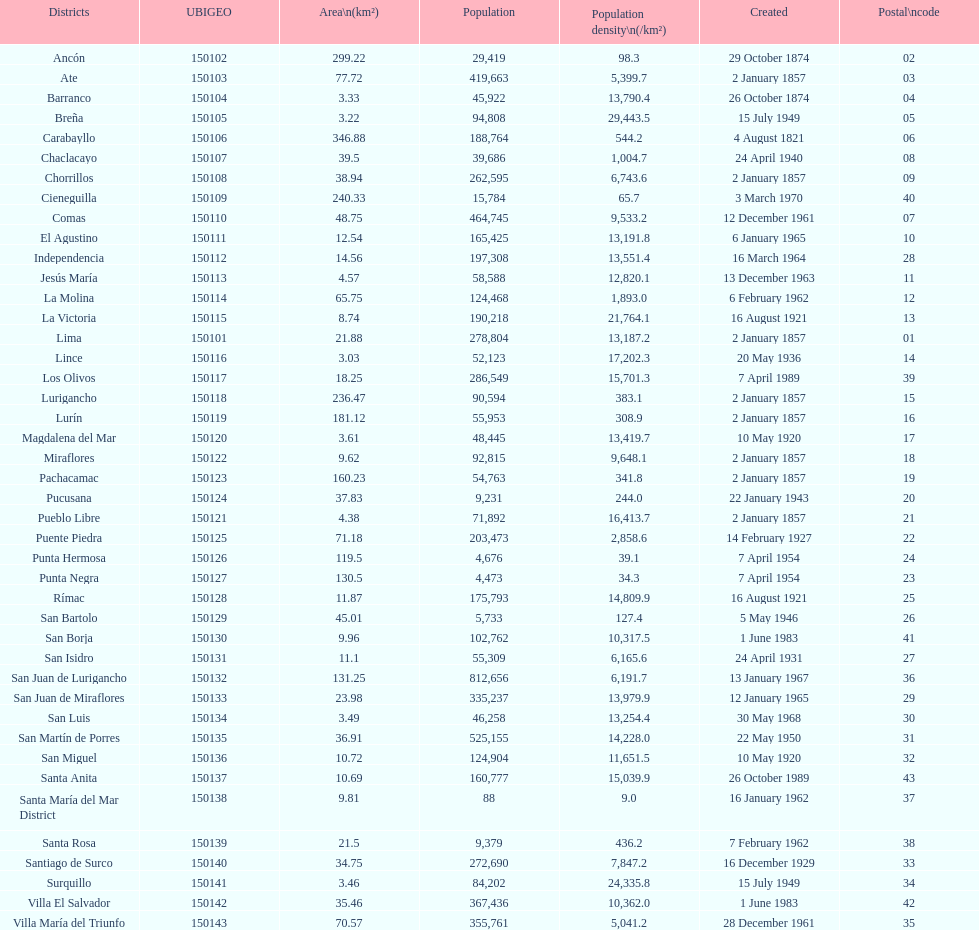Give me the full table as a dictionary. {'header': ['Districts', 'UBIGEO', 'Area\\n(km²)', 'Population', 'Population density\\n(/km²)', 'Created', 'Postal\\ncode'], 'rows': [['Ancón', '150102', '299.22', '29,419', '98.3', '29 October 1874', '02'], ['Ate', '150103', '77.72', '419,663', '5,399.7', '2 January 1857', '03'], ['Barranco', '150104', '3.33', '45,922', '13,790.4', '26 October 1874', '04'], ['Breña', '150105', '3.22', '94,808', '29,443.5', '15 July 1949', '05'], ['Carabayllo', '150106', '346.88', '188,764', '544.2', '4 August 1821', '06'], ['Chaclacayo', '150107', '39.5', '39,686', '1,004.7', '24 April 1940', '08'], ['Chorrillos', '150108', '38.94', '262,595', '6,743.6', '2 January 1857', '09'], ['Cieneguilla', '150109', '240.33', '15,784', '65.7', '3 March 1970', '40'], ['Comas', '150110', '48.75', '464,745', '9,533.2', '12 December 1961', '07'], ['El Agustino', '150111', '12.54', '165,425', '13,191.8', '6 January 1965', '10'], ['Independencia', '150112', '14.56', '197,308', '13,551.4', '16 March 1964', '28'], ['Jesús María', '150113', '4.57', '58,588', '12,820.1', '13 December 1963', '11'], ['La Molina', '150114', '65.75', '124,468', '1,893.0', '6 February 1962', '12'], ['La Victoria', '150115', '8.74', '190,218', '21,764.1', '16 August 1921', '13'], ['Lima', '150101', '21.88', '278,804', '13,187.2', '2 January 1857', '01'], ['Lince', '150116', '3.03', '52,123', '17,202.3', '20 May 1936', '14'], ['Los Olivos', '150117', '18.25', '286,549', '15,701.3', '7 April 1989', '39'], ['Lurigancho', '150118', '236.47', '90,594', '383.1', '2 January 1857', '15'], ['Lurín', '150119', '181.12', '55,953', '308.9', '2 January 1857', '16'], ['Magdalena del Mar', '150120', '3.61', '48,445', '13,419.7', '10 May 1920', '17'], ['Miraflores', '150122', '9.62', '92,815', '9,648.1', '2 January 1857', '18'], ['Pachacamac', '150123', '160.23', '54,763', '341.8', '2 January 1857', '19'], ['Pucusana', '150124', '37.83', '9,231', '244.0', '22 January 1943', '20'], ['Pueblo Libre', '150121', '4.38', '71,892', '16,413.7', '2 January 1857', '21'], ['Puente Piedra', '150125', '71.18', '203,473', '2,858.6', '14 February 1927', '22'], ['Punta Hermosa', '150126', '119.5', '4,676', '39.1', '7 April 1954', '24'], ['Punta Negra', '150127', '130.5', '4,473', '34.3', '7 April 1954', '23'], ['Rímac', '150128', '11.87', '175,793', '14,809.9', '16 August 1921', '25'], ['San Bartolo', '150129', '45.01', '5,733', '127.4', '5 May 1946', '26'], ['San Borja', '150130', '9.96', '102,762', '10,317.5', '1 June 1983', '41'], ['San Isidro', '150131', '11.1', '55,309', '6,165.6', '24 April 1931', '27'], ['San Juan de Lurigancho', '150132', '131.25', '812,656', '6,191.7', '13 January 1967', '36'], ['San Juan de Miraflores', '150133', '23.98', '335,237', '13,979.9', '12 January 1965', '29'], ['San Luis', '150134', '3.49', '46,258', '13,254.4', '30 May 1968', '30'], ['San Martín de Porres', '150135', '36.91', '525,155', '14,228.0', '22 May 1950', '31'], ['San Miguel', '150136', '10.72', '124,904', '11,651.5', '10 May 1920', '32'], ['Santa Anita', '150137', '10.69', '160,777', '15,039.9', '26 October 1989', '43'], ['Santa María del Mar District', '150138', '9.81', '88', '9.0', '16 January 1962', '37'], ['Santa Rosa', '150139', '21.5', '9,379', '436.2', '7 February 1962', '38'], ['Santiago de Surco', '150140', '34.75', '272,690', '7,847.2', '16 December 1929', '33'], ['Surquillo', '150141', '3.46', '84,202', '24,335.8', '15 July 1949', '34'], ['Villa El Salvador', '150142', '35.46', '367,436', '10,362.0', '1 June 1983', '42'], ['Villa María del Triunfo', '150143', '70.57', '355,761', '5,041.2', '28 December 1961', '35']]} Which district possesses the smallest number of inhabitants? Santa María del Mar District. 